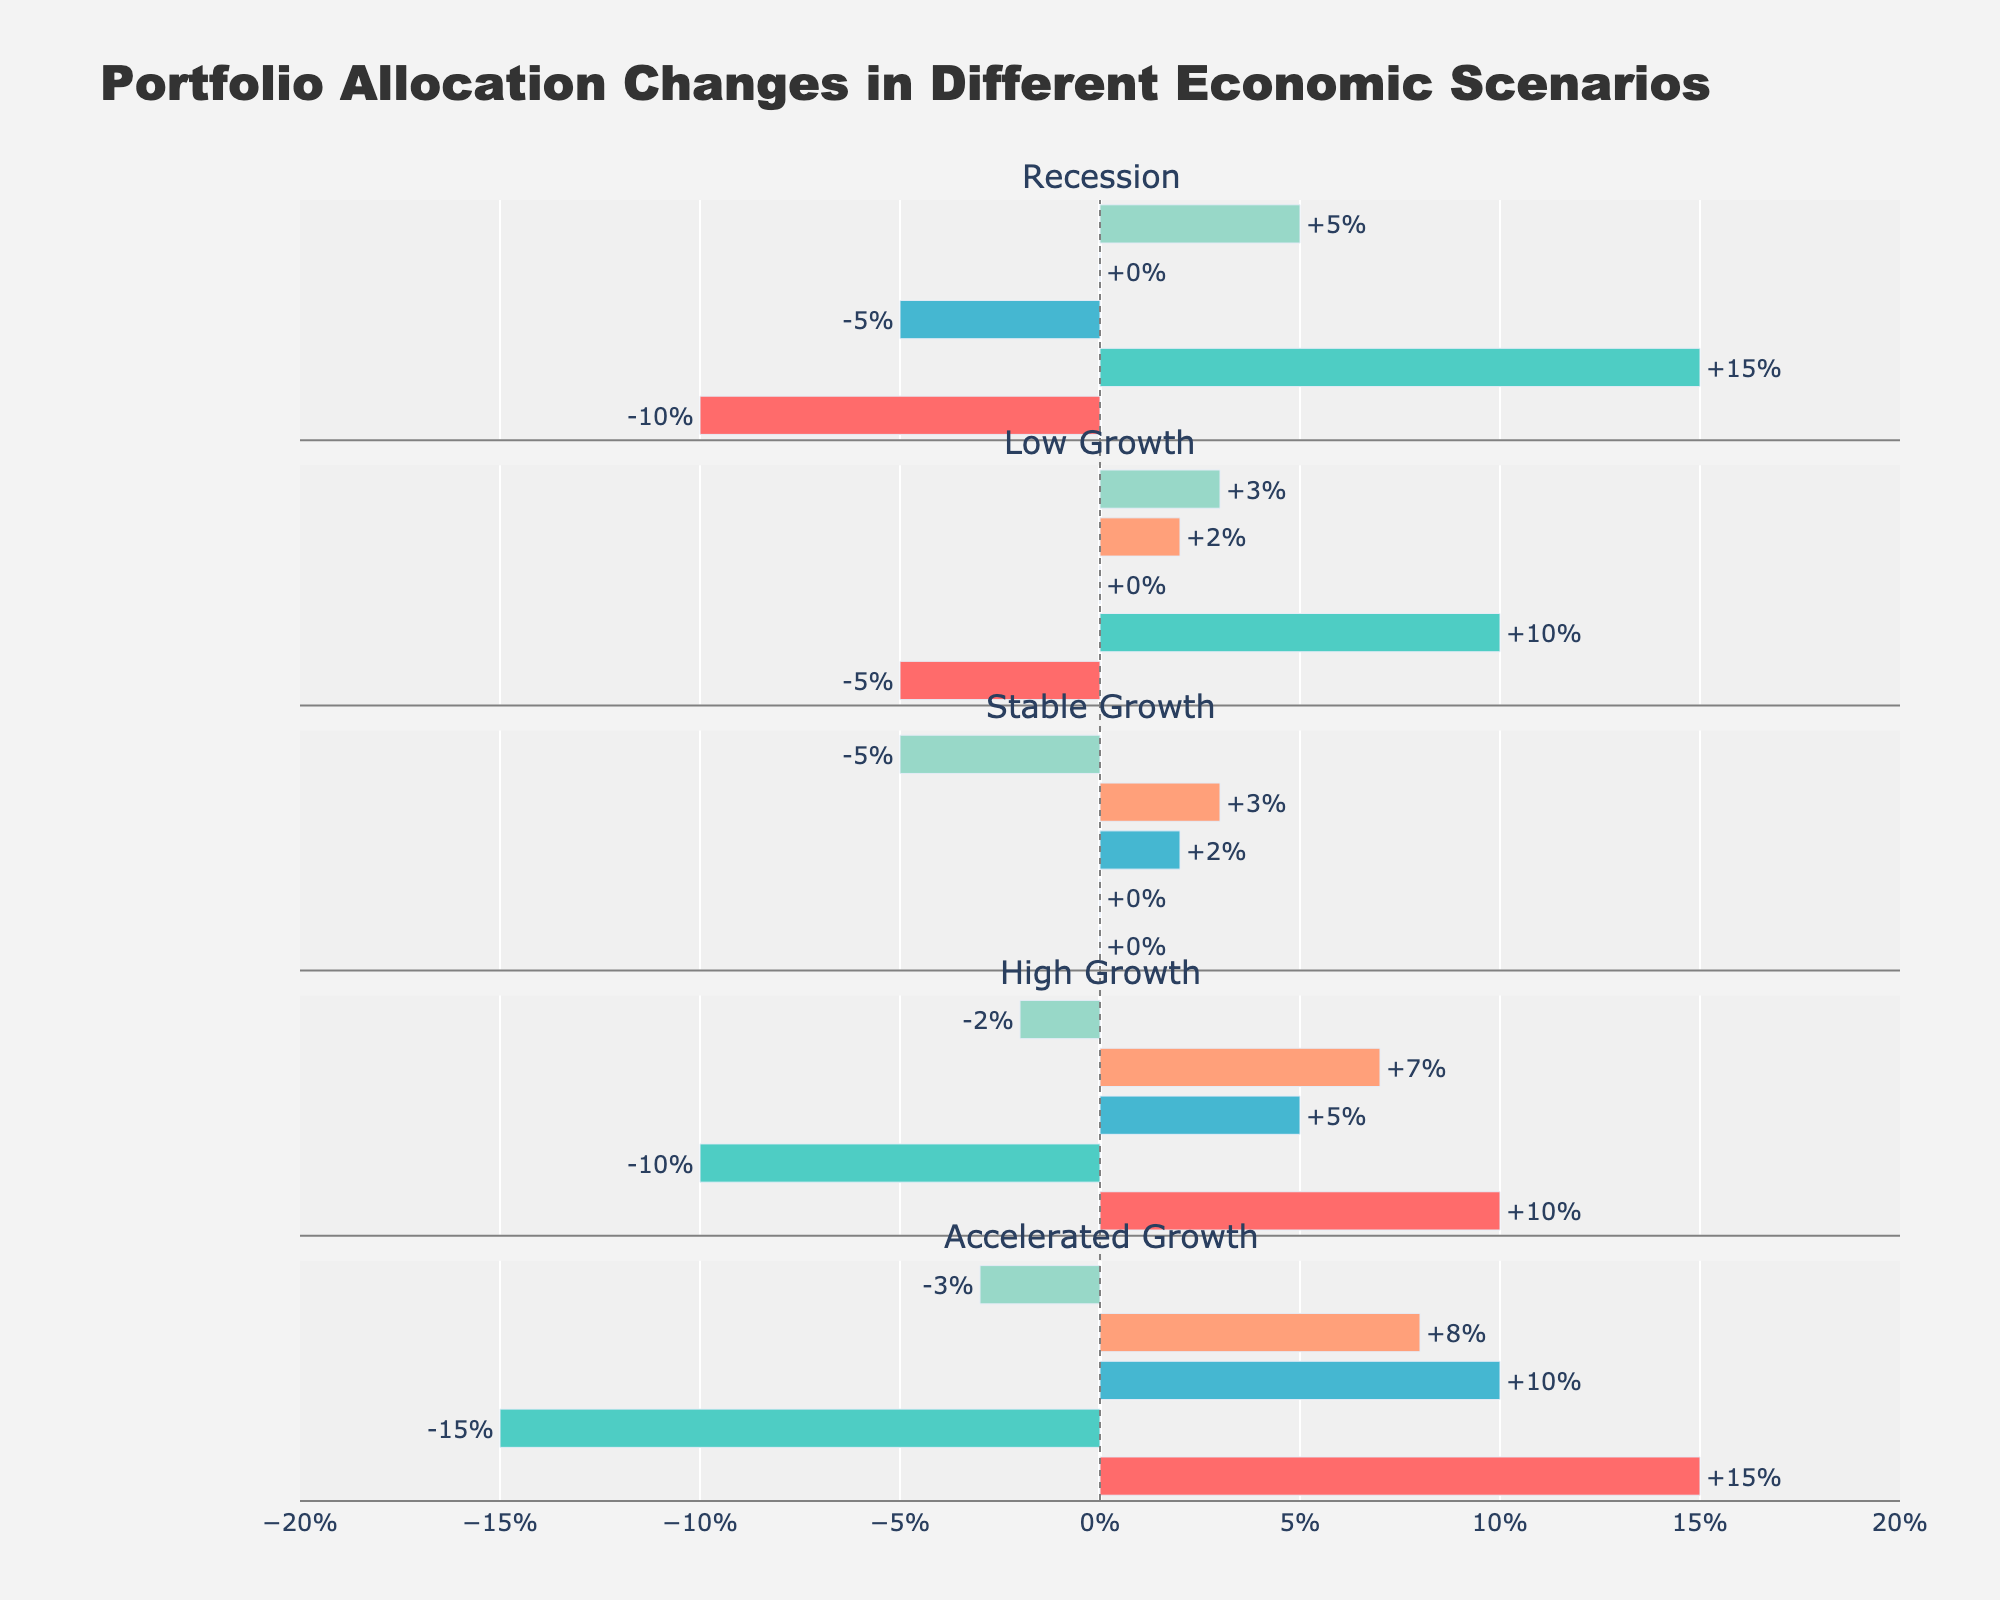Which economic scenario has the highest increase in Equities allocation? The bar representing Equities allocation increase is the longest for 'Accelerated Growth'. The bar extends to +15% in Equities.
Answer: Accelerated Growth Which asset class shows a consistent increase across all economic scenarios? In all economic scenarios, Real Estate shows either an increase or no change (0%) but no negative values.
Answer: Real Estate Compare the allocation changes in Equities under Recession and High Growth scenarios. Which one shows a greater increase? In the Recession scenario, Equities decrease by -10%, while in the High Growth scenario, Equities increase by +10%.
Answer: High Growth What is the sum of changes in allocation for Fixed Income across all scenarios? Summing the changes in Fixed Income: (+15) + (+10) + 0 + (-10) + (-15) = 0.
Answer: 0 Which economic scenario results in the highest decrease in Cash allocation? The longest negative bar in Cash allocation appears in the 'Stable Growth' scenario, extending to -5%.
Answer: Stable Growth What is the average change in Commodities allocation across all scenarios? The changes in Commodities allocation are -5, 0, +2, +5, and +10. The sum is 12. Therefore, the average is 12/5 = 2.4.
Answer: 2.4 During which economic scenario does Real Estate show the highest positive change? The highest positive change in Real Estate is observed in the 'Accelerated Growth' scenario, with an increase of +8%.
Answer: Accelerated Growth Compare Equities and Fixed Income allocations during Low Growth scenario. Which one has a higher positive change? For Low Growth, Equities decrease by -5%, and Fixed Income increases by +10%. Fixed Income has a higher positive change.
Answer: Fixed Income What is the total allocation change in the Recession scenario considering all asset classes? Summing the allocation changes in Recession: (-10) + (+15) + (-5) + 0 + (+5) = +5.
Answer: +5 Which economic scenario results in a decrease in both Equities and Fixed Income? The 'High Growth' and 'Accelerated Growth' scenarios result in decreases in both Equities (-10, -15) and Fixed Income (-10, -15) respectively.
Answer: High Growth, Accelerated Growth 